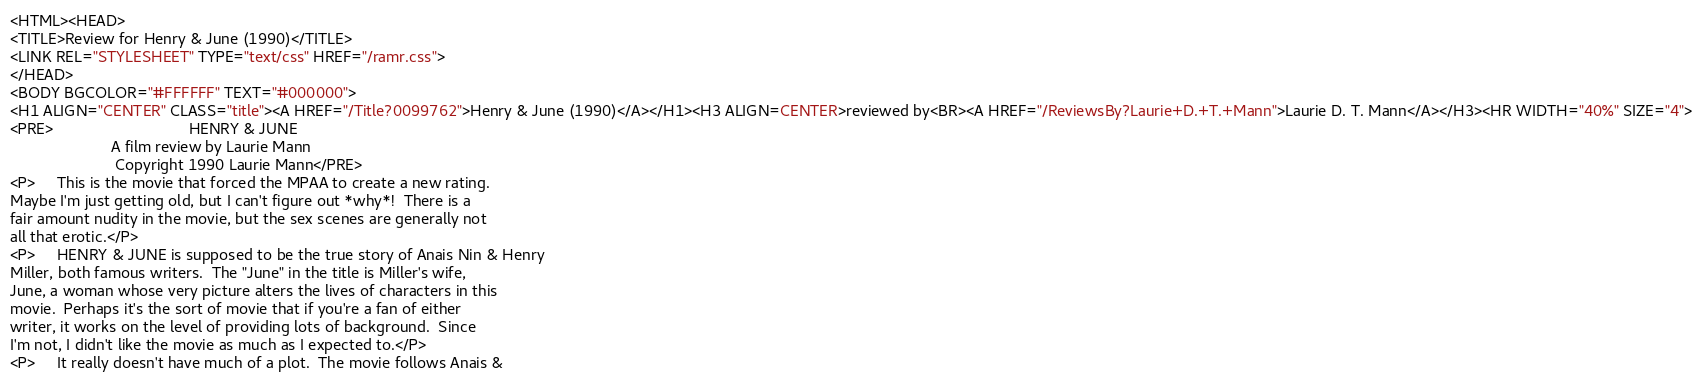<code> <loc_0><loc_0><loc_500><loc_500><_HTML_><HTML><HEAD>
<TITLE>Review for Henry & June (1990)</TITLE>
<LINK REL="STYLESHEET" TYPE="text/css" HREF="/ramr.css">
</HEAD>
<BODY BGCOLOR="#FFFFFF" TEXT="#000000">
<H1 ALIGN="CENTER" CLASS="title"><A HREF="/Title?0099762">Henry & June (1990)</A></H1><H3 ALIGN=CENTER>reviewed by<BR><A HREF="/ReviewsBy?Laurie+D.+T.+Mann">Laurie D. T. Mann</A></H3><HR WIDTH="40%" SIZE="4">
<PRE>                               HENRY & JUNE
                       A film review by Laurie Mann
                        Copyright 1990 Laurie Mann</PRE>
<P>     This is the movie that forced the MPAA to create a new rating.
Maybe I'm just getting old, but I can't figure out *why*!  There is a
fair amount nudity in the movie, but the sex scenes are generally not
all that erotic.</P>
<P>     HENRY & JUNE is supposed to be the true story of Anais Nin & Henry
Miller, both famous writers.  The "June" in the title is Miller's wife,
June, a woman whose very picture alters the lives of characters in this
movie.  Perhaps it's the sort of movie that if you're a fan of either
writer, it works on the level of providing lots of background.  Since
I'm not, I didn't like the movie as much as I expected to.</P>
<P>     It really doesn't have much of a plot.  The movie follows Anais &</code> 